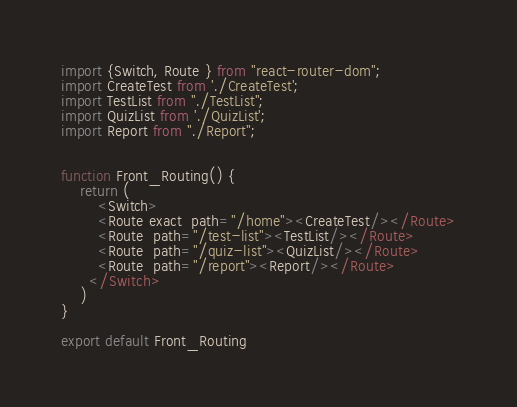<code> <loc_0><loc_0><loc_500><loc_500><_JavaScript_>import {Switch, Route } from "react-router-dom";
import CreateTest from './CreateTest';
import TestList from "./TestList";
import QuizList from './QuizList';
import Report from "./Report";


function Front_Routing() {   
    return (
        <Switch>         
        <Route exact  path="/home"><CreateTest/></Route>
        <Route  path="/test-list"><TestList/></Route>
        <Route  path="/quiz-list"><QuizList/></Route>
        <Route  path="/report"><Report/></Route>
      </Switch>
    )
}

export default Front_Routing
</code> 